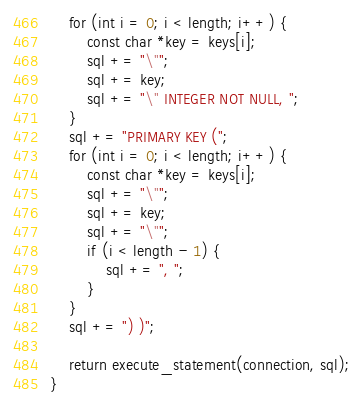<code> <loc_0><loc_0><loc_500><loc_500><_C++_>    for (int i = 0; i < length; i++) {
        const char *key = keys[i];
        sql += "\"";
        sql += key;
        sql += "\" INTEGER NOT NULL, ";
    }
    sql += "PRIMARY KEY (";
    for (int i = 0; i < length; i++) {
        const char *key = keys[i];
        sql += "\"";
        sql += key;
        sql += "\"";
        if (i < length - 1) {
            sql += ", ";
        }
    }
    sql += ") )";

    return execute_statement(connection, sql);
}
</code> 